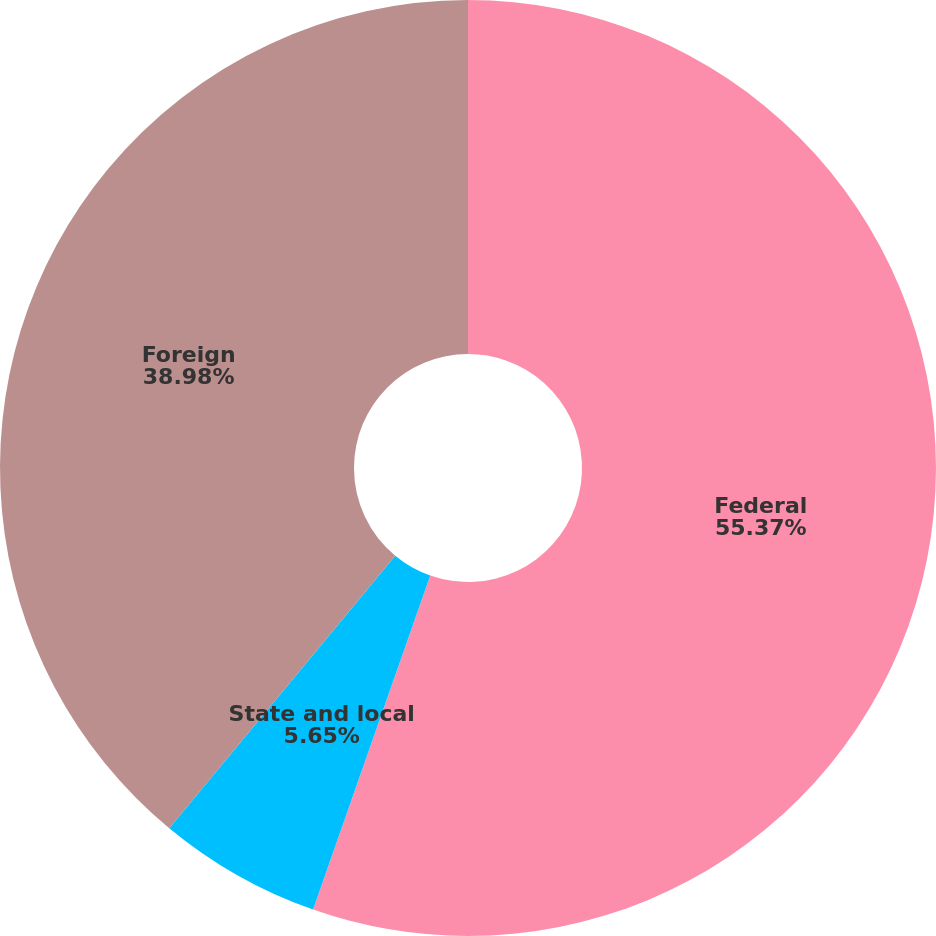Convert chart to OTSL. <chart><loc_0><loc_0><loc_500><loc_500><pie_chart><fcel>Federal<fcel>State and local<fcel>Foreign<nl><fcel>55.37%<fcel>5.65%<fcel>38.98%<nl></chart> 